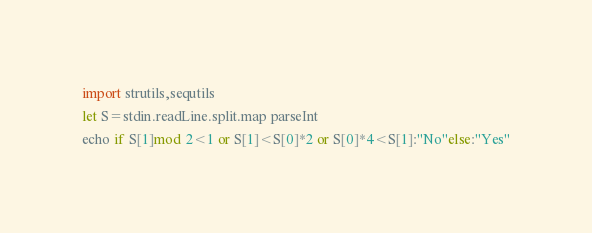<code> <loc_0><loc_0><loc_500><loc_500><_Nim_>import strutils,sequtils
let S=stdin.readLine.split.map parseInt
echo if S[1]mod 2<1 or S[1]<S[0]*2 or S[0]*4<S[1]:"No"else:"Yes"</code> 